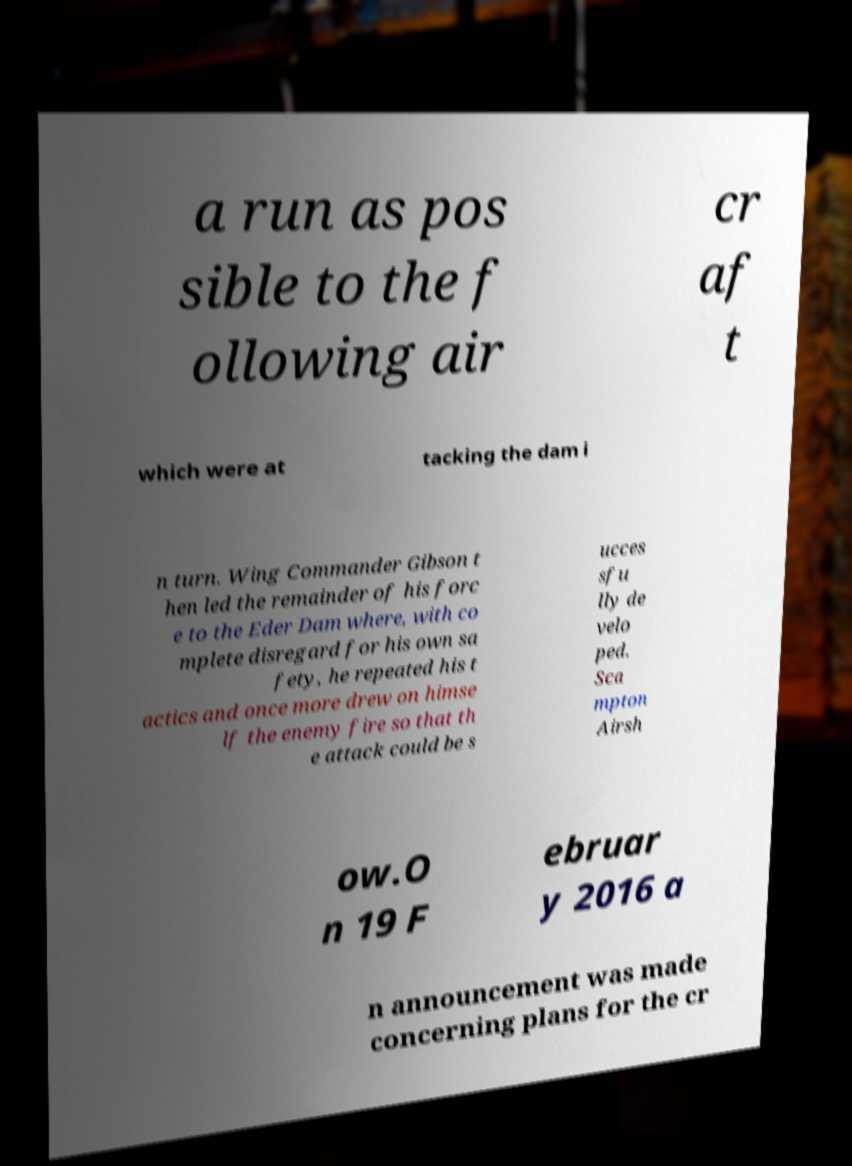Please read and relay the text visible in this image. What does it say? a run as pos sible to the f ollowing air cr af t which were at tacking the dam i n turn. Wing Commander Gibson t hen led the remainder of his forc e to the Eder Dam where, with co mplete disregard for his own sa fety, he repeated his t actics and once more drew on himse lf the enemy fire so that th e attack could be s ucces sfu lly de velo ped. Sca mpton Airsh ow.O n 19 F ebruar y 2016 a n announcement was made concerning plans for the cr 